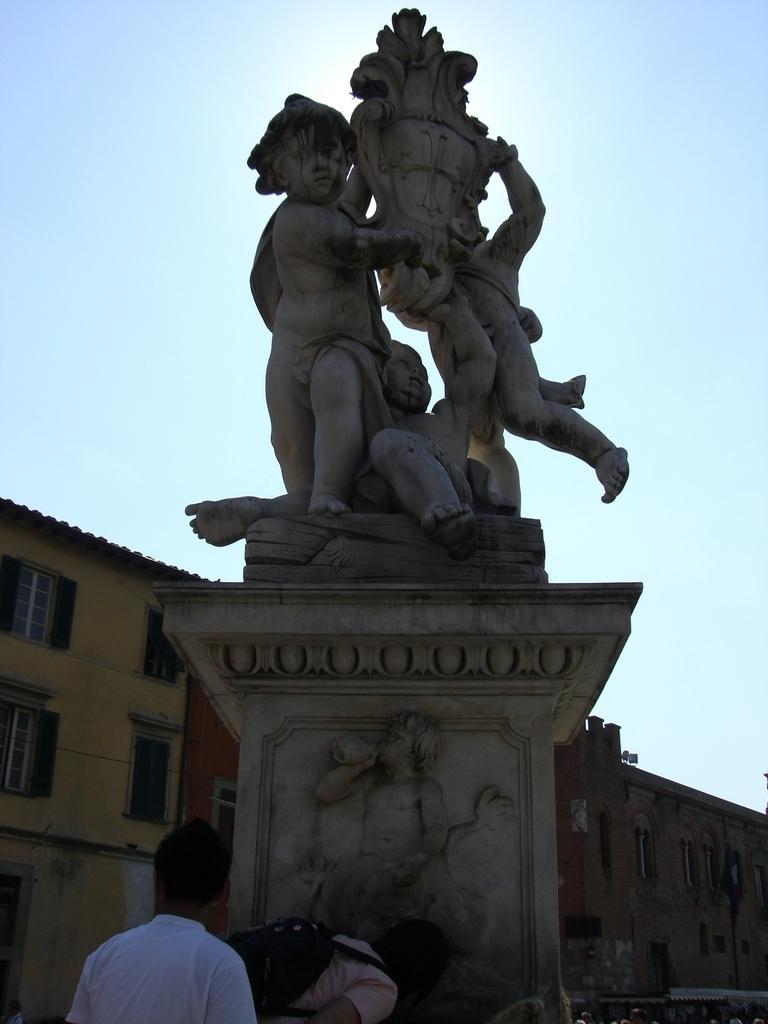How would you summarize this image in a sentence or two? In this picture there is a statue and there are two persons below it and there are buildings in the background. 